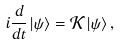Convert formula to latex. <formula><loc_0><loc_0><loc_500><loc_500>i \frac { d } { d t } \left | \psi \right \rangle = \mathcal { K } \left | \psi \right \rangle ,</formula> 